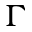<formula> <loc_0><loc_0><loc_500><loc_500>\Gamma</formula> 